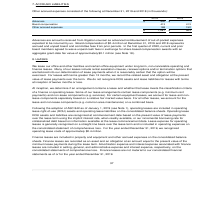According to Parkervision's financial document, What is note 7 about? According to the financial document, ACCRUED LIABILITIES. The relevant text states: "7. ACCRUED LIABILITIES..." Also, Which years information is included in this note? The document shows two values: 2018 and 2019. From the document: "penses consisted of the following at December 31, 2019 and 2018 (in thousands): nsisted of the following at December 31, 2019 and 2018 (in thousands):..." Also, What are advances? Advances are amounts received from litigation counsel as advanced reimbursement of out-of-pocket expenses expected to be incurred by us.. The document states: "Advances are amounts received from litigation counsel as advanced reimbursement of out-of-pocket expenses expected to be incurred by us. Board compens..." Additionally, How many categories of accrued liabilities are there? According to the financial document, 3. The relevant text states: "Board compensation 413 413..." Additionally, Which is the largest category (in amount) in 2019? According to the financial document, Advances. The relevant text states: "Advances $ 500 $ -..." Also, can you calculate: What is the total amount of the top 2 categories of accrued liabilities in 2019? Based on the calculation: 500 + 413, the result is 913 (in thousands). This is based on the information: "Board compensation 413 413 Advances $ 500 $ -..." The key data points involved are: 413, 500. 